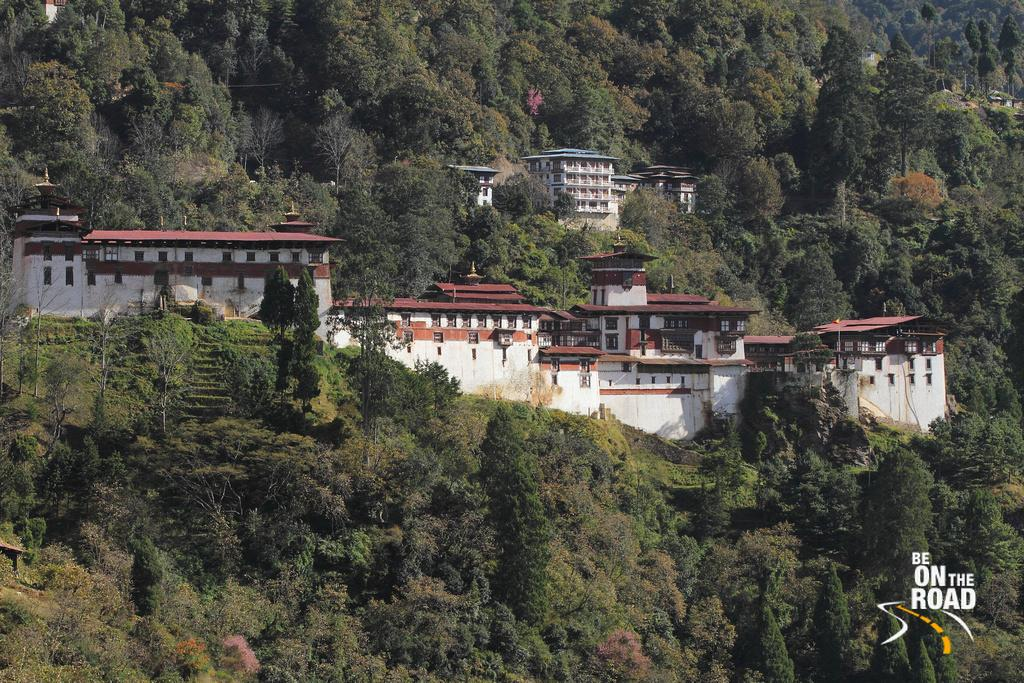What type of structures can be seen in the image? There are buildings in the image. What type of vegetation is present in the image? There are trees in the image. What type of behavior can be observed in the prison in the image? There is no prison present in the image, so it is not possible to observe any behavior in a prison. What type of conversation can be heard coming from the people in the image? There are no people or conversation present in the image, so it is not possible to hear any conversation. 